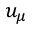Convert formula to latex. <formula><loc_0><loc_0><loc_500><loc_500>u _ { \mu }</formula> 